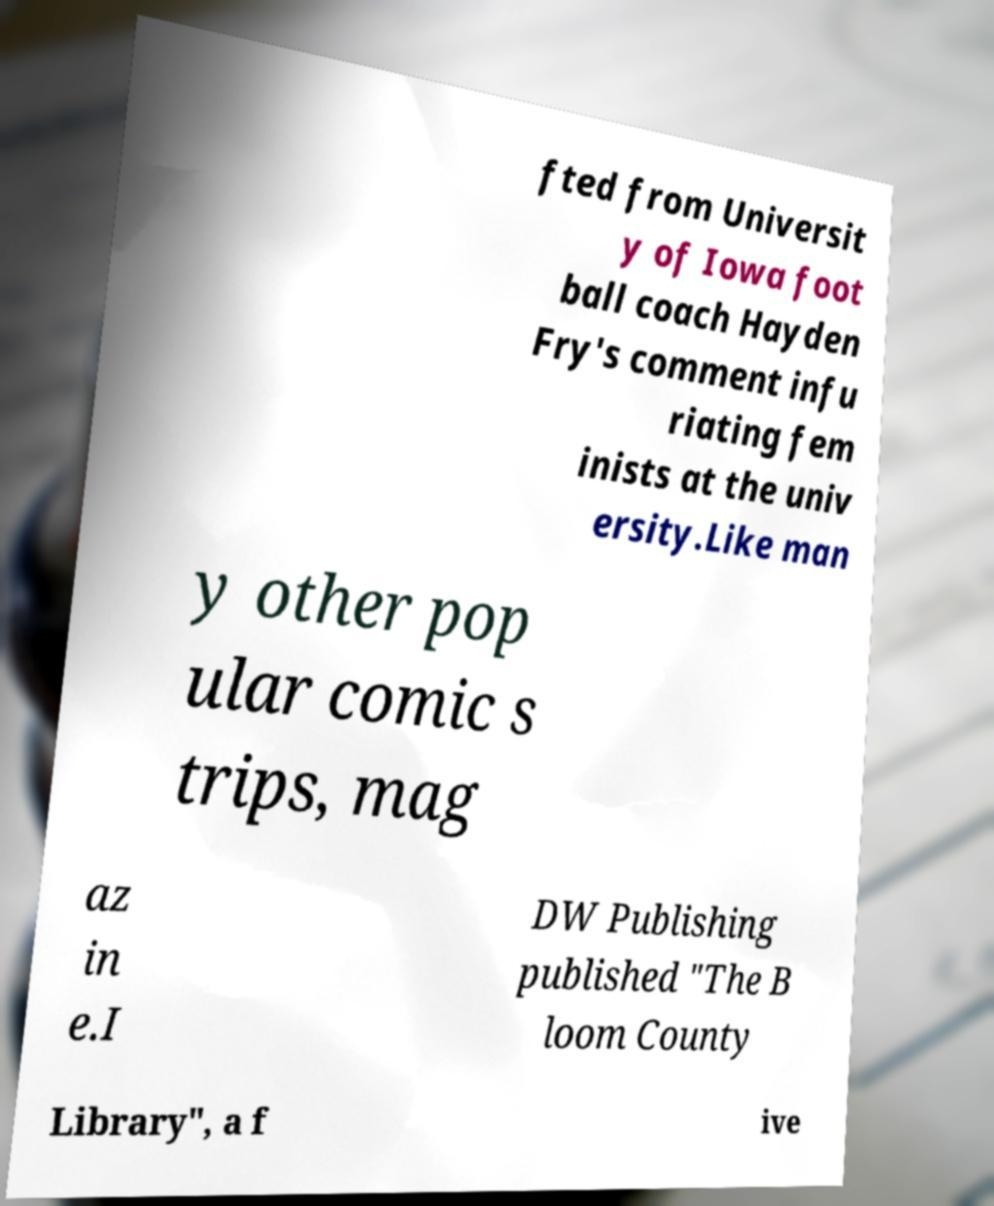There's text embedded in this image that I need extracted. Can you transcribe it verbatim? fted from Universit y of Iowa foot ball coach Hayden Fry's comment infu riating fem inists at the univ ersity.Like man y other pop ular comic s trips, mag az in e.I DW Publishing published "The B loom County Library", a f ive 